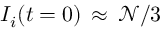<formula> <loc_0><loc_0><loc_500><loc_500>I _ { i } ( t = 0 ) \, \approx \, \mathcal { N } / 3</formula> 